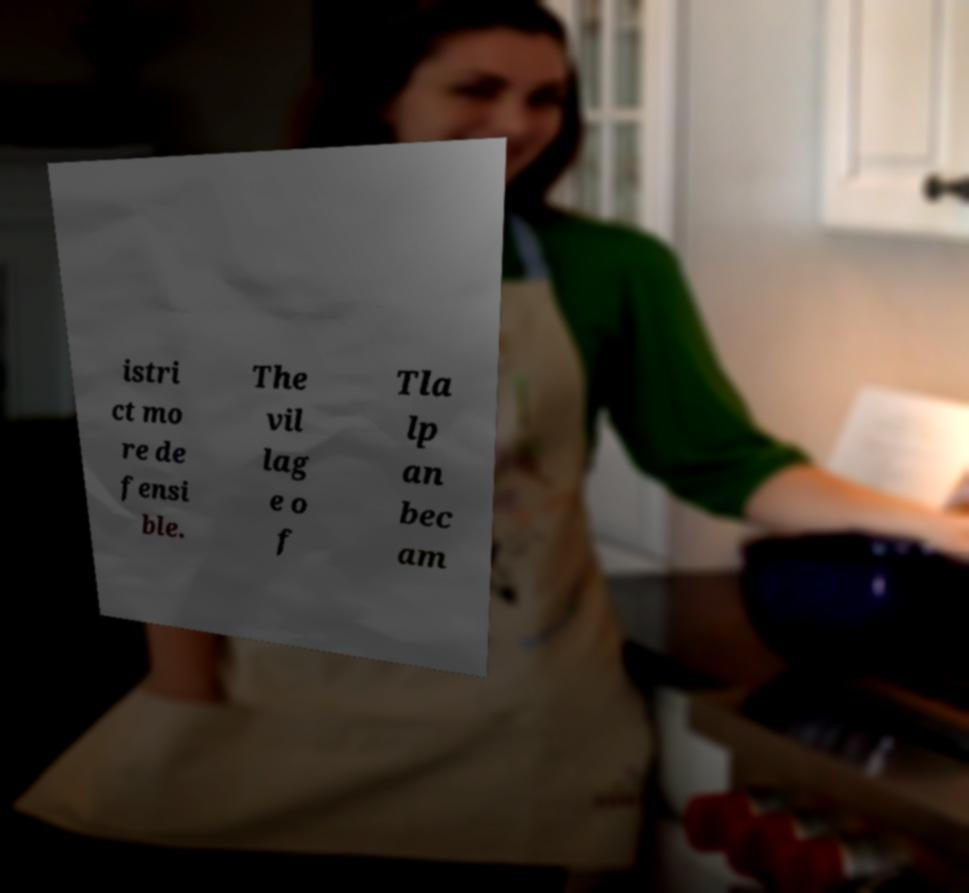Could you assist in decoding the text presented in this image and type it out clearly? istri ct mo re de fensi ble. The vil lag e o f Tla lp an bec am 